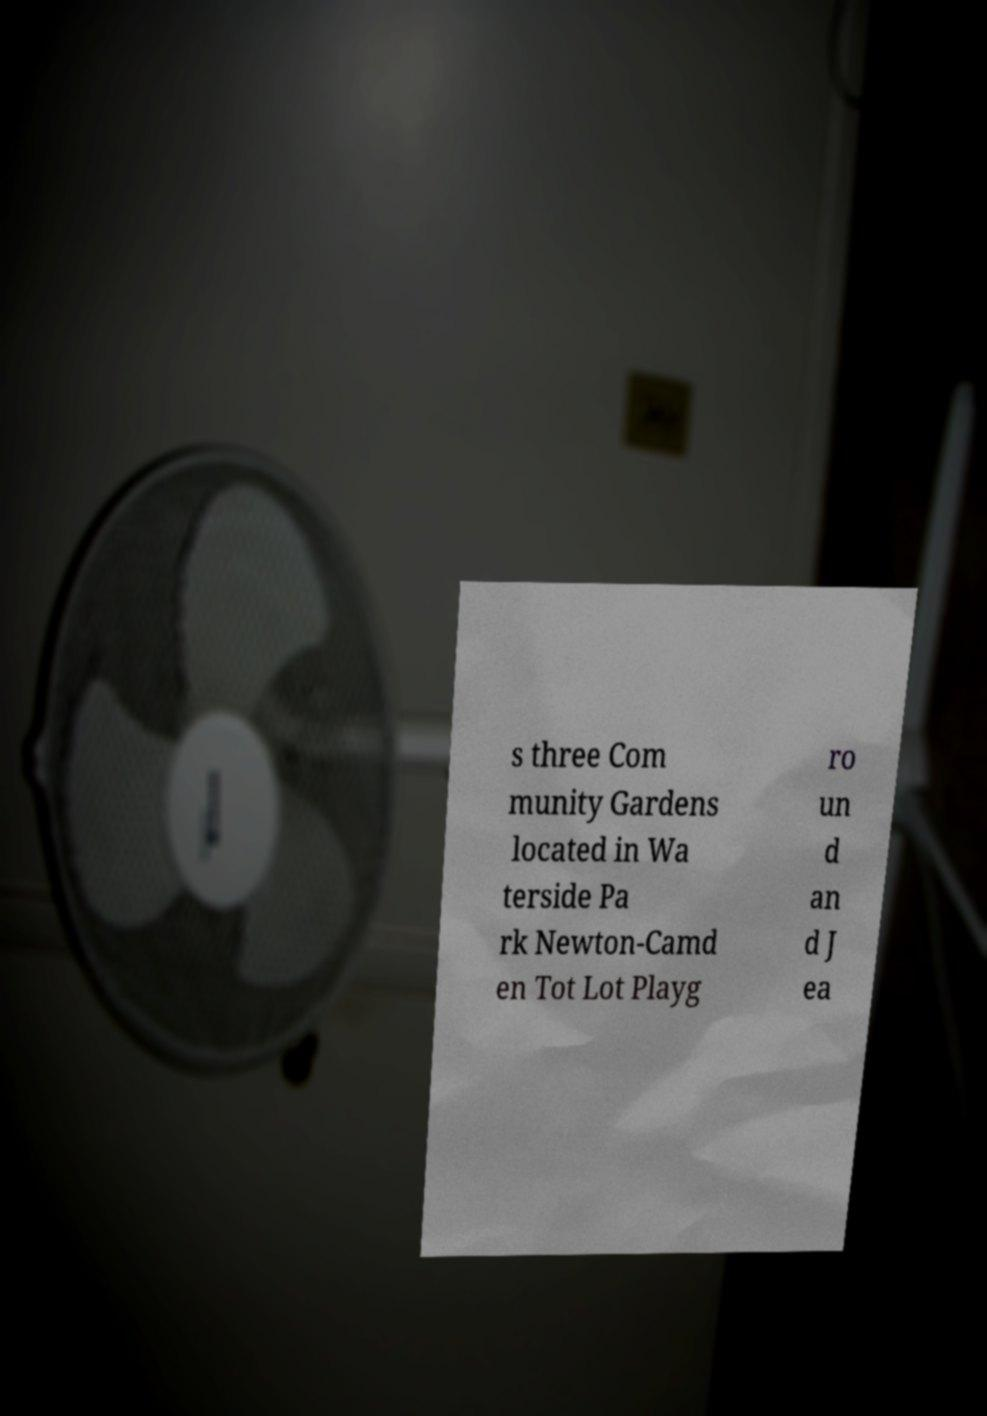Please read and relay the text visible in this image. What does it say? s three Com munity Gardens located in Wa terside Pa rk Newton-Camd en Tot Lot Playg ro un d an d J ea 